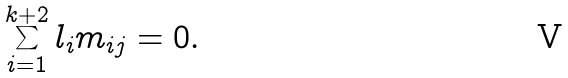<formula> <loc_0><loc_0><loc_500><loc_500>\sum _ { i = 1 } ^ { k + 2 } l _ { i } m _ { i j } = 0 .</formula> 